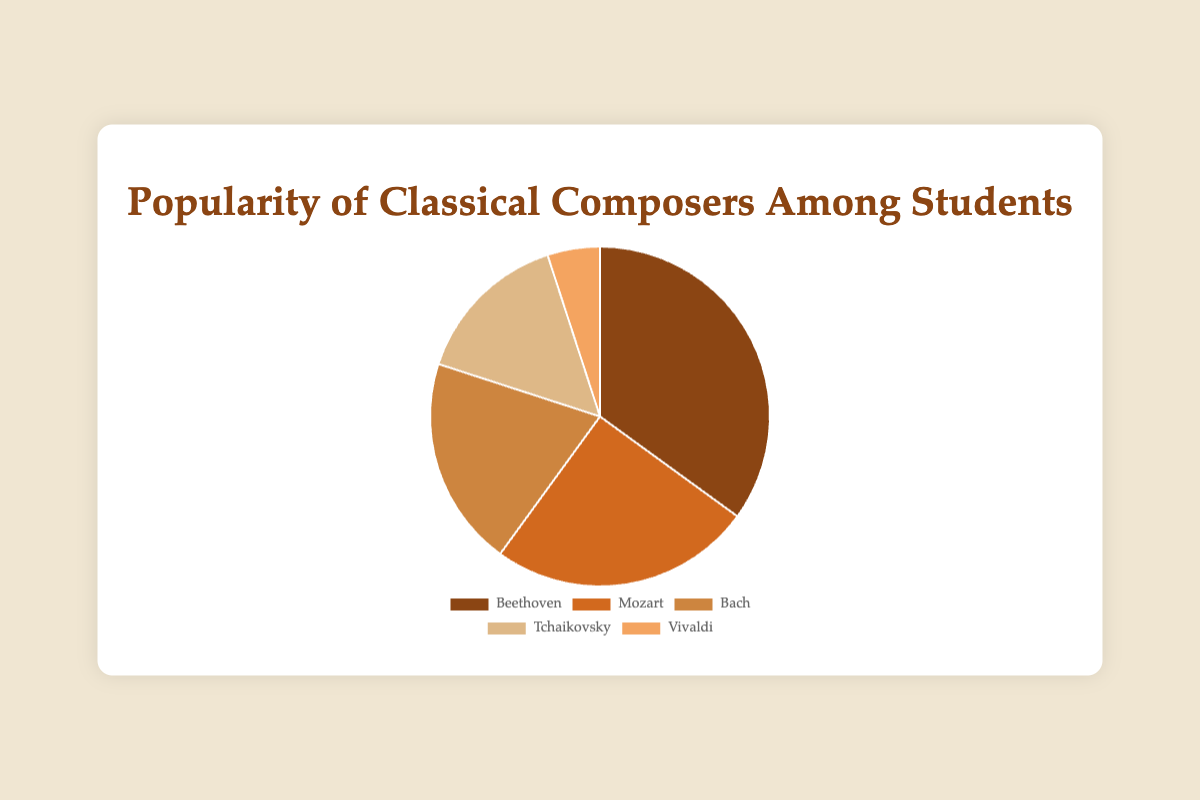Which composer has the highest popularity among students? By examining the pie chart, we observe that Beethoven occupies the largest arc, indicating the highest popularity.
Answer: Beethoven What percentage of students prefer Bach? According to the pie chart, the segment for Bach is labeled with his corresponding percentage of 20%.
Answer: 20% How much more popular is Beethoven compared to Mozart? Beethoven has a popularity of 35%, while Mozart has 25%. The difference is 35% - 25% = 10%.
Answer: 10% Which composer is the least popular among students? By looking at the pie chart, the smallest segment represents Vivaldi.
Answer: Vivaldi Sum up the percentage of students who prefer either Tchaikovsky or Vivaldi. Tchaikovsky has 15% and Vivaldi has 5%. Adding these gives 15% + 5% = 20%.
Answer: 20% Is Mozart more popular than Bach, and by how much? Mozart's popularity is 25%, while Bach's is 20%. The difference is 25% - 20% = 5%.
Answer: Yes, by 5% What is the combined popularity of Beethoven, Bach, and Vivaldi? Adding the percentages of Beethoven (35%), Bach (20%), and Vivaldi (5%) yields 35% + 20% + 5% = 60%.
Answer: 60% Which composer's segment is color-coded in brown? By examining the colors, Beethoven's segment is in brown.
Answer: Beethoven What is the average popularity percentage of all the composers? The total percentage is the sum of all individual percentages: 35% (Beethoven) + 25% (Mozart) + 20% (Bach) + 15% (Tchaikovsky) + 5% (Vivaldi) = 100%. The average is 100% / 5 = 20%.
Answer: 20% If the combined popularity of Mozart and Tchaikovsky surpass Beethoven's popularity, by how much? Mozart and Tchaikovsky together have 25% + 15% = 40%. Beethoven has 35%, so 40% - 35% = 5% more.
Answer: 5% more 